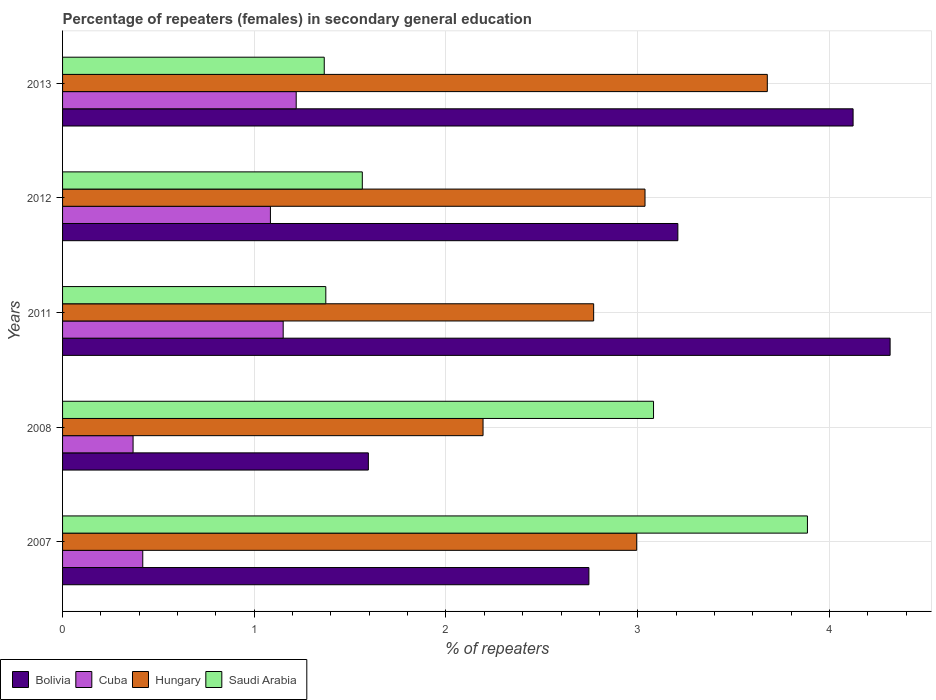How many different coloured bars are there?
Offer a terse response. 4. Are the number of bars per tick equal to the number of legend labels?
Give a very brief answer. Yes. Are the number of bars on each tick of the Y-axis equal?
Provide a succinct answer. Yes. How many bars are there on the 4th tick from the bottom?
Offer a terse response. 4. In how many cases, is the number of bars for a given year not equal to the number of legend labels?
Your response must be concise. 0. What is the percentage of female repeaters in Hungary in 2008?
Provide a succinct answer. 2.19. Across all years, what is the maximum percentage of female repeaters in Saudi Arabia?
Provide a succinct answer. 3.89. Across all years, what is the minimum percentage of female repeaters in Cuba?
Provide a succinct answer. 0.37. What is the total percentage of female repeaters in Hungary in the graph?
Provide a succinct answer. 14.67. What is the difference between the percentage of female repeaters in Cuba in 2011 and that in 2013?
Provide a succinct answer. -0.07. What is the difference between the percentage of female repeaters in Bolivia in 2013 and the percentage of female repeaters in Saudi Arabia in 2012?
Provide a short and direct response. 2.56. What is the average percentage of female repeaters in Bolivia per year?
Provide a succinct answer. 3.2. In the year 2013, what is the difference between the percentage of female repeaters in Saudi Arabia and percentage of female repeaters in Hungary?
Your response must be concise. -2.31. What is the ratio of the percentage of female repeaters in Cuba in 2007 to that in 2008?
Provide a short and direct response. 1.14. Is the percentage of female repeaters in Cuba in 2008 less than that in 2012?
Provide a succinct answer. Yes. Is the difference between the percentage of female repeaters in Saudi Arabia in 2011 and 2013 greater than the difference between the percentage of female repeaters in Hungary in 2011 and 2013?
Ensure brevity in your answer.  Yes. What is the difference between the highest and the second highest percentage of female repeaters in Hungary?
Make the answer very short. 0.64. What is the difference between the highest and the lowest percentage of female repeaters in Hungary?
Provide a short and direct response. 1.48. In how many years, is the percentage of female repeaters in Bolivia greater than the average percentage of female repeaters in Bolivia taken over all years?
Provide a short and direct response. 3. What does the 1st bar from the top in 2011 represents?
Your answer should be compact. Saudi Arabia. Are all the bars in the graph horizontal?
Your answer should be very brief. Yes. Are the values on the major ticks of X-axis written in scientific E-notation?
Your answer should be compact. No. Does the graph contain any zero values?
Your response must be concise. No. How many legend labels are there?
Your answer should be very brief. 4. How are the legend labels stacked?
Offer a terse response. Horizontal. What is the title of the graph?
Your response must be concise. Percentage of repeaters (females) in secondary general education. What is the label or title of the X-axis?
Give a very brief answer. % of repeaters. What is the % of repeaters in Bolivia in 2007?
Make the answer very short. 2.75. What is the % of repeaters in Cuba in 2007?
Make the answer very short. 0.42. What is the % of repeaters of Hungary in 2007?
Your response must be concise. 2.99. What is the % of repeaters of Saudi Arabia in 2007?
Offer a terse response. 3.89. What is the % of repeaters in Bolivia in 2008?
Give a very brief answer. 1.6. What is the % of repeaters of Cuba in 2008?
Offer a terse response. 0.37. What is the % of repeaters in Hungary in 2008?
Your answer should be compact. 2.19. What is the % of repeaters in Saudi Arabia in 2008?
Make the answer very short. 3.08. What is the % of repeaters in Bolivia in 2011?
Ensure brevity in your answer.  4.32. What is the % of repeaters in Cuba in 2011?
Your answer should be very brief. 1.15. What is the % of repeaters in Hungary in 2011?
Keep it short and to the point. 2.77. What is the % of repeaters of Saudi Arabia in 2011?
Ensure brevity in your answer.  1.37. What is the % of repeaters in Bolivia in 2012?
Offer a terse response. 3.21. What is the % of repeaters in Cuba in 2012?
Offer a terse response. 1.08. What is the % of repeaters of Hungary in 2012?
Keep it short and to the point. 3.04. What is the % of repeaters of Saudi Arabia in 2012?
Provide a succinct answer. 1.56. What is the % of repeaters in Bolivia in 2013?
Provide a short and direct response. 4.12. What is the % of repeaters of Cuba in 2013?
Ensure brevity in your answer.  1.22. What is the % of repeaters of Hungary in 2013?
Make the answer very short. 3.68. What is the % of repeaters in Saudi Arabia in 2013?
Offer a very short reply. 1.36. Across all years, what is the maximum % of repeaters of Bolivia?
Provide a succinct answer. 4.32. Across all years, what is the maximum % of repeaters in Cuba?
Provide a short and direct response. 1.22. Across all years, what is the maximum % of repeaters of Hungary?
Your response must be concise. 3.68. Across all years, what is the maximum % of repeaters of Saudi Arabia?
Make the answer very short. 3.89. Across all years, what is the minimum % of repeaters in Bolivia?
Provide a succinct answer. 1.6. Across all years, what is the minimum % of repeaters in Cuba?
Your answer should be very brief. 0.37. Across all years, what is the minimum % of repeaters in Hungary?
Your answer should be very brief. 2.19. Across all years, what is the minimum % of repeaters in Saudi Arabia?
Your answer should be compact. 1.36. What is the total % of repeaters in Bolivia in the graph?
Provide a short and direct response. 15.99. What is the total % of repeaters in Cuba in the graph?
Your answer should be compact. 4.24. What is the total % of repeaters of Hungary in the graph?
Make the answer very short. 14.67. What is the total % of repeaters of Saudi Arabia in the graph?
Your answer should be compact. 11.27. What is the difference between the % of repeaters of Bolivia in 2007 and that in 2008?
Keep it short and to the point. 1.15. What is the difference between the % of repeaters in Cuba in 2007 and that in 2008?
Keep it short and to the point. 0.05. What is the difference between the % of repeaters in Hungary in 2007 and that in 2008?
Ensure brevity in your answer.  0.8. What is the difference between the % of repeaters in Saudi Arabia in 2007 and that in 2008?
Your answer should be very brief. 0.8. What is the difference between the % of repeaters in Bolivia in 2007 and that in 2011?
Provide a short and direct response. -1.57. What is the difference between the % of repeaters of Cuba in 2007 and that in 2011?
Provide a short and direct response. -0.73. What is the difference between the % of repeaters of Hungary in 2007 and that in 2011?
Offer a very short reply. 0.22. What is the difference between the % of repeaters of Saudi Arabia in 2007 and that in 2011?
Offer a very short reply. 2.51. What is the difference between the % of repeaters in Bolivia in 2007 and that in 2012?
Offer a terse response. -0.46. What is the difference between the % of repeaters of Cuba in 2007 and that in 2012?
Your answer should be very brief. -0.67. What is the difference between the % of repeaters in Hungary in 2007 and that in 2012?
Provide a succinct answer. -0.04. What is the difference between the % of repeaters of Saudi Arabia in 2007 and that in 2012?
Offer a terse response. 2.32. What is the difference between the % of repeaters in Bolivia in 2007 and that in 2013?
Your answer should be very brief. -1.38. What is the difference between the % of repeaters of Cuba in 2007 and that in 2013?
Offer a very short reply. -0.8. What is the difference between the % of repeaters in Hungary in 2007 and that in 2013?
Your answer should be very brief. -0.68. What is the difference between the % of repeaters of Saudi Arabia in 2007 and that in 2013?
Offer a terse response. 2.52. What is the difference between the % of repeaters in Bolivia in 2008 and that in 2011?
Make the answer very short. -2.72. What is the difference between the % of repeaters of Cuba in 2008 and that in 2011?
Give a very brief answer. -0.78. What is the difference between the % of repeaters of Hungary in 2008 and that in 2011?
Offer a terse response. -0.58. What is the difference between the % of repeaters of Saudi Arabia in 2008 and that in 2011?
Your answer should be compact. 1.71. What is the difference between the % of repeaters of Bolivia in 2008 and that in 2012?
Provide a succinct answer. -1.61. What is the difference between the % of repeaters of Cuba in 2008 and that in 2012?
Offer a very short reply. -0.72. What is the difference between the % of repeaters in Hungary in 2008 and that in 2012?
Give a very brief answer. -0.84. What is the difference between the % of repeaters in Saudi Arabia in 2008 and that in 2012?
Keep it short and to the point. 1.52. What is the difference between the % of repeaters in Bolivia in 2008 and that in 2013?
Your response must be concise. -2.53. What is the difference between the % of repeaters in Cuba in 2008 and that in 2013?
Make the answer very short. -0.85. What is the difference between the % of repeaters of Hungary in 2008 and that in 2013?
Provide a succinct answer. -1.48. What is the difference between the % of repeaters in Saudi Arabia in 2008 and that in 2013?
Give a very brief answer. 1.72. What is the difference between the % of repeaters of Bolivia in 2011 and that in 2012?
Ensure brevity in your answer.  1.11. What is the difference between the % of repeaters of Cuba in 2011 and that in 2012?
Provide a succinct answer. 0.07. What is the difference between the % of repeaters in Hungary in 2011 and that in 2012?
Ensure brevity in your answer.  -0.27. What is the difference between the % of repeaters of Saudi Arabia in 2011 and that in 2012?
Ensure brevity in your answer.  -0.19. What is the difference between the % of repeaters of Bolivia in 2011 and that in 2013?
Keep it short and to the point. 0.19. What is the difference between the % of repeaters in Cuba in 2011 and that in 2013?
Offer a terse response. -0.07. What is the difference between the % of repeaters of Hungary in 2011 and that in 2013?
Provide a succinct answer. -0.91. What is the difference between the % of repeaters in Saudi Arabia in 2011 and that in 2013?
Your answer should be compact. 0.01. What is the difference between the % of repeaters of Bolivia in 2012 and that in 2013?
Keep it short and to the point. -0.91. What is the difference between the % of repeaters of Cuba in 2012 and that in 2013?
Your answer should be compact. -0.13. What is the difference between the % of repeaters of Hungary in 2012 and that in 2013?
Your answer should be compact. -0.64. What is the difference between the % of repeaters of Saudi Arabia in 2012 and that in 2013?
Give a very brief answer. 0.2. What is the difference between the % of repeaters of Bolivia in 2007 and the % of repeaters of Cuba in 2008?
Give a very brief answer. 2.38. What is the difference between the % of repeaters in Bolivia in 2007 and the % of repeaters in Hungary in 2008?
Make the answer very short. 0.55. What is the difference between the % of repeaters in Bolivia in 2007 and the % of repeaters in Saudi Arabia in 2008?
Keep it short and to the point. -0.34. What is the difference between the % of repeaters of Cuba in 2007 and the % of repeaters of Hungary in 2008?
Your response must be concise. -1.77. What is the difference between the % of repeaters in Cuba in 2007 and the % of repeaters in Saudi Arabia in 2008?
Provide a short and direct response. -2.66. What is the difference between the % of repeaters in Hungary in 2007 and the % of repeaters in Saudi Arabia in 2008?
Your answer should be very brief. -0.09. What is the difference between the % of repeaters in Bolivia in 2007 and the % of repeaters in Cuba in 2011?
Your answer should be compact. 1.59. What is the difference between the % of repeaters in Bolivia in 2007 and the % of repeaters in Hungary in 2011?
Provide a short and direct response. -0.02. What is the difference between the % of repeaters of Bolivia in 2007 and the % of repeaters of Saudi Arabia in 2011?
Make the answer very short. 1.37. What is the difference between the % of repeaters of Cuba in 2007 and the % of repeaters of Hungary in 2011?
Offer a terse response. -2.35. What is the difference between the % of repeaters in Cuba in 2007 and the % of repeaters in Saudi Arabia in 2011?
Provide a short and direct response. -0.95. What is the difference between the % of repeaters of Hungary in 2007 and the % of repeaters of Saudi Arabia in 2011?
Give a very brief answer. 1.62. What is the difference between the % of repeaters of Bolivia in 2007 and the % of repeaters of Cuba in 2012?
Make the answer very short. 1.66. What is the difference between the % of repeaters of Bolivia in 2007 and the % of repeaters of Hungary in 2012?
Offer a very short reply. -0.29. What is the difference between the % of repeaters of Bolivia in 2007 and the % of repeaters of Saudi Arabia in 2012?
Provide a succinct answer. 1.18. What is the difference between the % of repeaters in Cuba in 2007 and the % of repeaters in Hungary in 2012?
Make the answer very short. -2.62. What is the difference between the % of repeaters of Cuba in 2007 and the % of repeaters of Saudi Arabia in 2012?
Your answer should be compact. -1.15. What is the difference between the % of repeaters of Hungary in 2007 and the % of repeaters of Saudi Arabia in 2012?
Provide a short and direct response. 1.43. What is the difference between the % of repeaters of Bolivia in 2007 and the % of repeaters of Cuba in 2013?
Give a very brief answer. 1.53. What is the difference between the % of repeaters in Bolivia in 2007 and the % of repeaters in Hungary in 2013?
Make the answer very short. -0.93. What is the difference between the % of repeaters of Bolivia in 2007 and the % of repeaters of Saudi Arabia in 2013?
Ensure brevity in your answer.  1.38. What is the difference between the % of repeaters of Cuba in 2007 and the % of repeaters of Hungary in 2013?
Your response must be concise. -3.26. What is the difference between the % of repeaters of Cuba in 2007 and the % of repeaters of Saudi Arabia in 2013?
Offer a very short reply. -0.95. What is the difference between the % of repeaters in Hungary in 2007 and the % of repeaters in Saudi Arabia in 2013?
Keep it short and to the point. 1.63. What is the difference between the % of repeaters in Bolivia in 2008 and the % of repeaters in Cuba in 2011?
Keep it short and to the point. 0.44. What is the difference between the % of repeaters of Bolivia in 2008 and the % of repeaters of Hungary in 2011?
Make the answer very short. -1.18. What is the difference between the % of repeaters in Bolivia in 2008 and the % of repeaters in Saudi Arabia in 2011?
Provide a succinct answer. 0.22. What is the difference between the % of repeaters in Cuba in 2008 and the % of repeaters in Hungary in 2011?
Your answer should be very brief. -2.4. What is the difference between the % of repeaters in Cuba in 2008 and the % of repeaters in Saudi Arabia in 2011?
Provide a short and direct response. -1.01. What is the difference between the % of repeaters of Hungary in 2008 and the % of repeaters of Saudi Arabia in 2011?
Make the answer very short. 0.82. What is the difference between the % of repeaters of Bolivia in 2008 and the % of repeaters of Cuba in 2012?
Ensure brevity in your answer.  0.51. What is the difference between the % of repeaters of Bolivia in 2008 and the % of repeaters of Hungary in 2012?
Your answer should be very brief. -1.44. What is the difference between the % of repeaters in Bolivia in 2008 and the % of repeaters in Saudi Arabia in 2012?
Give a very brief answer. 0.03. What is the difference between the % of repeaters of Cuba in 2008 and the % of repeaters of Hungary in 2012?
Your answer should be compact. -2.67. What is the difference between the % of repeaters in Cuba in 2008 and the % of repeaters in Saudi Arabia in 2012?
Provide a short and direct response. -1.2. What is the difference between the % of repeaters in Hungary in 2008 and the % of repeaters in Saudi Arabia in 2012?
Make the answer very short. 0.63. What is the difference between the % of repeaters of Bolivia in 2008 and the % of repeaters of Cuba in 2013?
Your answer should be very brief. 0.38. What is the difference between the % of repeaters of Bolivia in 2008 and the % of repeaters of Hungary in 2013?
Make the answer very short. -2.08. What is the difference between the % of repeaters in Bolivia in 2008 and the % of repeaters in Saudi Arabia in 2013?
Make the answer very short. 0.23. What is the difference between the % of repeaters in Cuba in 2008 and the % of repeaters in Hungary in 2013?
Make the answer very short. -3.31. What is the difference between the % of repeaters of Cuba in 2008 and the % of repeaters of Saudi Arabia in 2013?
Give a very brief answer. -1. What is the difference between the % of repeaters of Hungary in 2008 and the % of repeaters of Saudi Arabia in 2013?
Provide a succinct answer. 0.83. What is the difference between the % of repeaters of Bolivia in 2011 and the % of repeaters of Cuba in 2012?
Provide a short and direct response. 3.23. What is the difference between the % of repeaters in Bolivia in 2011 and the % of repeaters in Hungary in 2012?
Offer a very short reply. 1.28. What is the difference between the % of repeaters in Bolivia in 2011 and the % of repeaters in Saudi Arabia in 2012?
Give a very brief answer. 2.75. What is the difference between the % of repeaters of Cuba in 2011 and the % of repeaters of Hungary in 2012?
Your answer should be very brief. -1.89. What is the difference between the % of repeaters in Cuba in 2011 and the % of repeaters in Saudi Arabia in 2012?
Offer a very short reply. -0.41. What is the difference between the % of repeaters of Hungary in 2011 and the % of repeaters of Saudi Arabia in 2012?
Keep it short and to the point. 1.21. What is the difference between the % of repeaters of Bolivia in 2011 and the % of repeaters of Cuba in 2013?
Provide a succinct answer. 3.1. What is the difference between the % of repeaters of Bolivia in 2011 and the % of repeaters of Hungary in 2013?
Your answer should be very brief. 0.64. What is the difference between the % of repeaters of Bolivia in 2011 and the % of repeaters of Saudi Arabia in 2013?
Ensure brevity in your answer.  2.95. What is the difference between the % of repeaters of Cuba in 2011 and the % of repeaters of Hungary in 2013?
Make the answer very short. -2.53. What is the difference between the % of repeaters in Cuba in 2011 and the % of repeaters in Saudi Arabia in 2013?
Make the answer very short. -0.21. What is the difference between the % of repeaters in Hungary in 2011 and the % of repeaters in Saudi Arabia in 2013?
Keep it short and to the point. 1.41. What is the difference between the % of repeaters in Bolivia in 2012 and the % of repeaters in Cuba in 2013?
Provide a short and direct response. 1.99. What is the difference between the % of repeaters of Bolivia in 2012 and the % of repeaters of Hungary in 2013?
Keep it short and to the point. -0.47. What is the difference between the % of repeaters of Bolivia in 2012 and the % of repeaters of Saudi Arabia in 2013?
Your response must be concise. 1.84. What is the difference between the % of repeaters in Cuba in 2012 and the % of repeaters in Hungary in 2013?
Your answer should be very brief. -2.59. What is the difference between the % of repeaters in Cuba in 2012 and the % of repeaters in Saudi Arabia in 2013?
Offer a very short reply. -0.28. What is the difference between the % of repeaters in Hungary in 2012 and the % of repeaters in Saudi Arabia in 2013?
Offer a very short reply. 1.67. What is the average % of repeaters of Bolivia per year?
Offer a terse response. 3.2. What is the average % of repeaters of Cuba per year?
Make the answer very short. 0.85. What is the average % of repeaters in Hungary per year?
Provide a succinct answer. 2.93. What is the average % of repeaters of Saudi Arabia per year?
Your answer should be very brief. 2.25. In the year 2007, what is the difference between the % of repeaters of Bolivia and % of repeaters of Cuba?
Ensure brevity in your answer.  2.33. In the year 2007, what is the difference between the % of repeaters in Bolivia and % of repeaters in Hungary?
Your response must be concise. -0.25. In the year 2007, what is the difference between the % of repeaters of Bolivia and % of repeaters of Saudi Arabia?
Keep it short and to the point. -1.14. In the year 2007, what is the difference between the % of repeaters of Cuba and % of repeaters of Hungary?
Offer a terse response. -2.58. In the year 2007, what is the difference between the % of repeaters of Cuba and % of repeaters of Saudi Arabia?
Provide a succinct answer. -3.47. In the year 2007, what is the difference between the % of repeaters in Hungary and % of repeaters in Saudi Arabia?
Provide a succinct answer. -0.89. In the year 2008, what is the difference between the % of repeaters of Bolivia and % of repeaters of Cuba?
Give a very brief answer. 1.23. In the year 2008, what is the difference between the % of repeaters of Bolivia and % of repeaters of Hungary?
Provide a short and direct response. -0.6. In the year 2008, what is the difference between the % of repeaters of Bolivia and % of repeaters of Saudi Arabia?
Offer a very short reply. -1.49. In the year 2008, what is the difference between the % of repeaters in Cuba and % of repeaters in Hungary?
Ensure brevity in your answer.  -1.83. In the year 2008, what is the difference between the % of repeaters in Cuba and % of repeaters in Saudi Arabia?
Your answer should be compact. -2.71. In the year 2008, what is the difference between the % of repeaters in Hungary and % of repeaters in Saudi Arabia?
Give a very brief answer. -0.89. In the year 2011, what is the difference between the % of repeaters of Bolivia and % of repeaters of Cuba?
Offer a terse response. 3.17. In the year 2011, what is the difference between the % of repeaters of Bolivia and % of repeaters of Hungary?
Provide a short and direct response. 1.55. In the year 2011, what is the difference between the % of repeaters of Bolivia and % of repeaters of Saudi Arabia?
Provide a succinct answer. 2.94. In the year 2011, what is the difference between the % of repeaters in Cuba and % of repeaters in Hungary?
Your answer should be compact. -1.62. In the year 2011, what is the difference between the % of repeaters of Cuba and % of repeaters of Saudi Arabia?
Provide a short and direct response. -0.22. In the year 2011, what is the difference between the % of repeaters in Hungary and % of repeaters in Saudi Arabia?
Your answer should be very brief. 1.4. In the year 2012, what is the difference between the % of repeaters of Bolivia and % of repeaters of Cuba?
Provide a succinct answer. 2.13. In the year 2012, what is the difference between the % of repeaters in Bolivia and % of repeaters in Hungary?
Ensure brevity in your answer.  0.17. In the year 2012, what is the difference between the % of repeaters of Bolivia and % of repeaters of Saudi Arabia?
Provide a succinct answer. 1.65. In the year 2012, what is the difference between the % of repeaters in Cuba and % of repeaters in Hungary?
Your response must be concise. -1.95. In the year 2012, what is the difference between the % of repeaters in Cuba and % of repeaters in Saudi Arabia?
Ensure brevity in your answer.  -0.48. In the year 2012, what is the difference between the % of repeaters of Hungary and % of repeaters of Saudi Arabia?
Provide a short and direct response. 1.47. In the year 2013, what is the difference between the % of repeaters in Bolivia and % of repeaters in Cuba?
Your answer should be very brief. 2.9. In the year 2013, what is the difference between the % of repeaters in Bolivia and % of repeaters in Hungary?
Your response must be concise. 0.45. In the year 2013, what is the difference between the % of repeaters in Bolivia and % of repeaters in Saudi Arabia?
Provide a short and direct response. 2.76. In the year 2013, what is the difference between the % of repeaters of Cuba and % of repeaters of Hungary?
Your response must be concise. -2.46. In the year 2013, what is the difference between the % of repeaters in Cuba and % of repeaters in Saudi Arabia?
Your answer should be compact. -0.15. In the year 2013, what is the difference between the % of repeaters of Hungary and % of repeaters of Saudi Arabia?
Make the answer very short. 2.31. What is the ratio of the % of repeaters in Bolivia in 2007 to that in 2008?
Your answer should be compact. 1.72. What is the ratio of the % of repeaters in Cuba in 2007 to that in 2008?
Your answer should be very brief. 1.14. What is the ratio of the % of repeaters of Hungary in 2007 to that in 2008?
Offer a very short reply. 1.37. What is the ratio of the % of repeaters of Saudi Arabia in 2007 to that in 2008?
Your response must be concise. 1.26. What is the ratio of the % of repeaters of Bolivia in 2007 to that in 2011?
Keep it short and to the point. 0.64. What is the ratio of the % of repeaters in Cuba in 2007 to that in 2011?
Make the answer very short. 0.36. What is the ratio of the % of repeaters of Hungary in 2007 to that in 2011?
Keep it short and to the point. 1.08. What is the ratio of the % of repeaters of Saudi Arabia in 2007 to that in 2011?
Keep it short and to the point. 2.83. What is the ratio of the % of repeaters in Bolivia in 2007 to that in 2012?
Offer a very short reply. 0.86. What is the ratio of the % of repeaters of Cuba in 2007 to that in 2012?
Your answer should be very brief. 0.39. What is the ratio of the % of repeaters in Hungary in 2007 to that in 2012?
Make the answer very short. 0.99. What is the ratio of the % of repeaters of Saudi Arabia in 2007 to that in 2012?
Offer a terse response. 2.49. What is the ratio of the % of repeaters in Bolivia in 2007 to that in 2013?
Your answer should be very brief. 0.67. What is the ratio of the % of repeaters in Cuba in 2007 to that in 2013?
Your answer should be very brief. 0.34. What is the ratio of the % of repeaters in Hungary in 2007 to that in 2013?
Provide a succinct answer. 0.81. What is the ratio of the % of repeaters in Saudi Arabia in 2007 to that in 2013?
Provide a short and direct response. 2.85. What is the ratio of the % of repeaters of Bolivia in 2008 to that in 2011?
Give a very brief answer. 0.37. What is the ratio of the % of repeaters of Cuba in 2008 to that in 2011?
Keep it short and to the point. 0.32. What is the ratio of the % of repeaters in Hungary in 2008 to that in 2011?
Provide a succinct answer. 0.79. What is the ratio of the % of repeaters in Saudi Arabia in 2008 to that in 2011?
Your response must be concise. 2.24. What is the ratio of the % of repeaters in Bolivia in 2008 to that in 2012?
Provide a succinct answer. 0.5. What is the ratio of the % of repeaters in Cuba in 2008 to that in 2012?
Provide a succinct answer. 0.34. What is the ratio of the % of repeaters in Hungary in 2008 to that in 2012?
Offer a very short reply. 0.72. What is the ratio of the % of repeaters in Saudi Arabia in 2008 to that in 2012?
Provide a short and direct response. 1.97. What is the ratio of the % of repeaters of Bolivia in 2008 to that in 2013?
Your answer should be compact. 0.39. What is the ratio of the % of repeaters in Cuba in 2008 to that in 2013?
Make the answer very short. 0.3. What is the ratio of the % of repeaters of Hungary in 2008 to that in 2013?
Your answer should be compact. 0.6. What is the ratio of the % of repeaters of Saudi Arabia in 2008 to that in 2013?
Make the answer very short. 2.26. What is the ratio of the % of repeaters in Bolivia in 2011 to that in 2012?
Keep it short and to the point. 1.34. What is the ratio of the % of repeaters in Cuba in 2011 to that in 2012?
Your answer should be very brief. 1.06. What is the ratio of the % of repeaters in Hungary in 2011 to that in 2012?
Offer a very short reply. 0.91. What is the ratio of the % of repeaters in Saudi Arabia in 2011 to that in 2012?
Your answer should be very brief. 0.88. What is the ratio of the % of repeaters in Bolivia in 2011 to that in 2013?
Provide a succinct answer. 1.05. What is the ratio of the % of repeaters in Cuba in 2011 to that in 2013?
Your answer should be very brief. 0.94. What is the ratio of the % of repeaters of Hungary in 2011 to that in 2013?
Keep it short and to the point. 0.75. What is the ratio of the % of repeaters of Saudi Arabia in 2011 to that in 2013?
Your answer should be compact. 1.01. What is the ratio of the % of repeaters in Bolivia in 2012 to that in 2013?
Your response must be concise. 0.78. What is the ratio of the % of repeaters in Cuba in 2012 to that in 2013?
Ensure brevity in your answer.  0.89. What is the ratio of the % of repeaters of Hungary in 2012 to that in 2013?
Your answer should be compact. 0.83. What is the ratio of the % of repeaters in Saudi Arabia in 2012 to that in 2013?
Provide a succinct answer. 1.15. What is the difference between the highest and the second highest % of repeaters in Bolivia?
Give a very brief answer. 0.19. What is the difference between the highest and the second highest % of repeaters of Cuba?
Offer a terse response. 0.07. What is the difference between the highest and the second highest % of repeaters of Hungary?
Make the answer very short. 0.64. What is the difference between the highest and the second highest % of repeaters in Saudi Arabia?
Make the answer very short. 0.8. What is the difference between the highest and the lowest % of repeaters of Bolivia?
Provide a short and direct response. 2.72. What is the difference between the highest and the lowest % of repeaters of Cuba?
Your response must be concise. 0.85. What is the difference between the highest and the lowest % of repeaters of Hungary?
Give a very brief answer. 1.48. What is the difference between the highest and the lowest % of repeaters in Saudi Arabia?
Offer a very short reply. 2.52. 